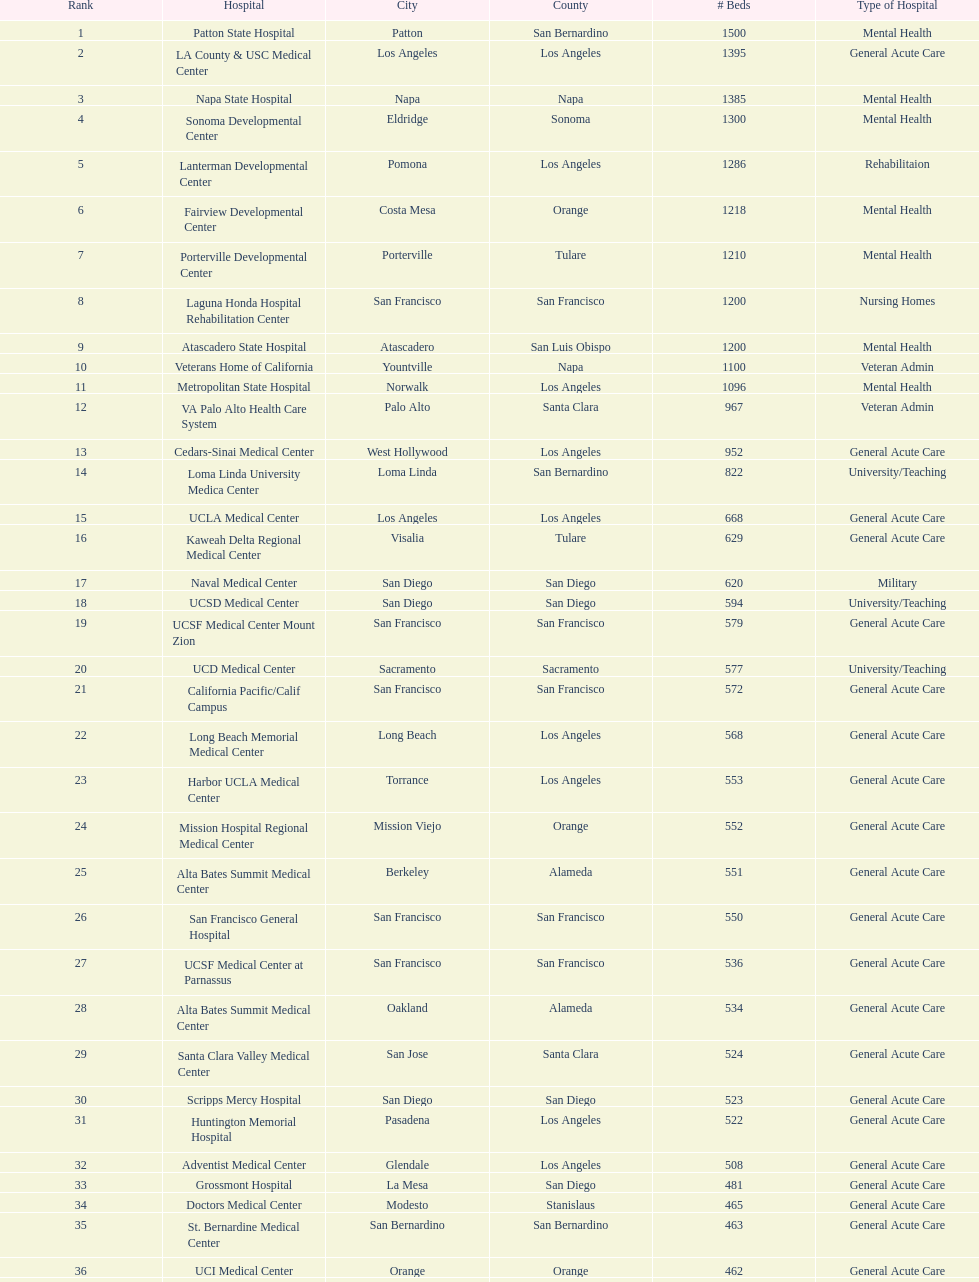What was the difference in bed capacity between the biggest hospital in california and the 50th biggest? 1071. 